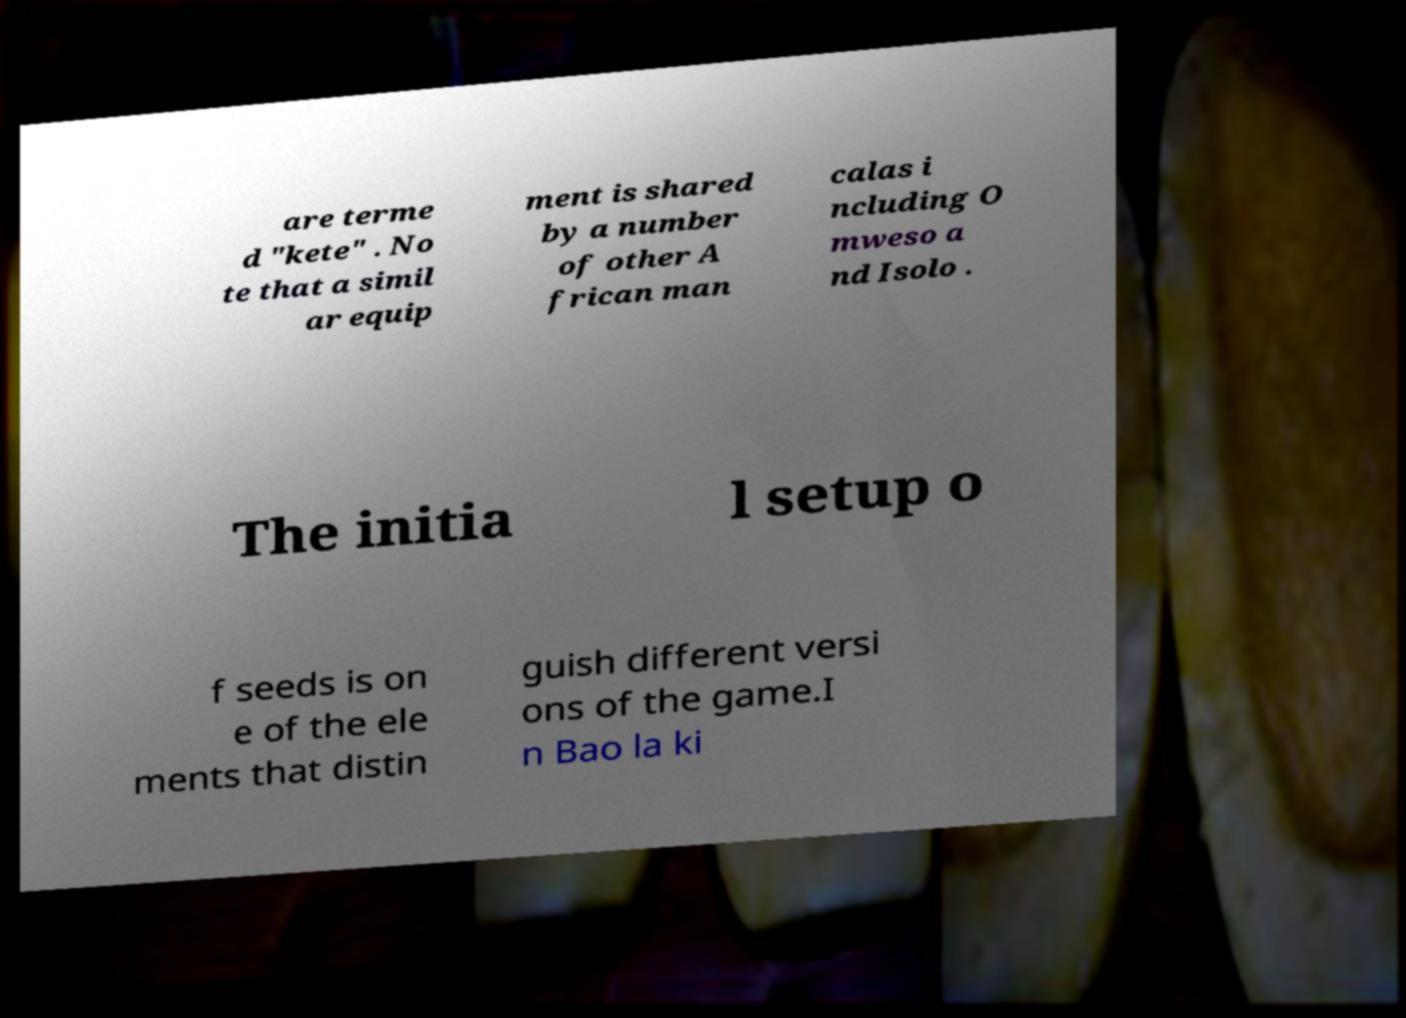Can you accurately transcribe the text from the provided image for me? are terme d "kete" . No te that a simil ar equip ment is shared by a number of other A frican man calas i ncluding O mweso a nd Isolo . The initia l setup o f seeds is on e of the ele ments that distin guish different versi ons of the game.I n Bao la ki 